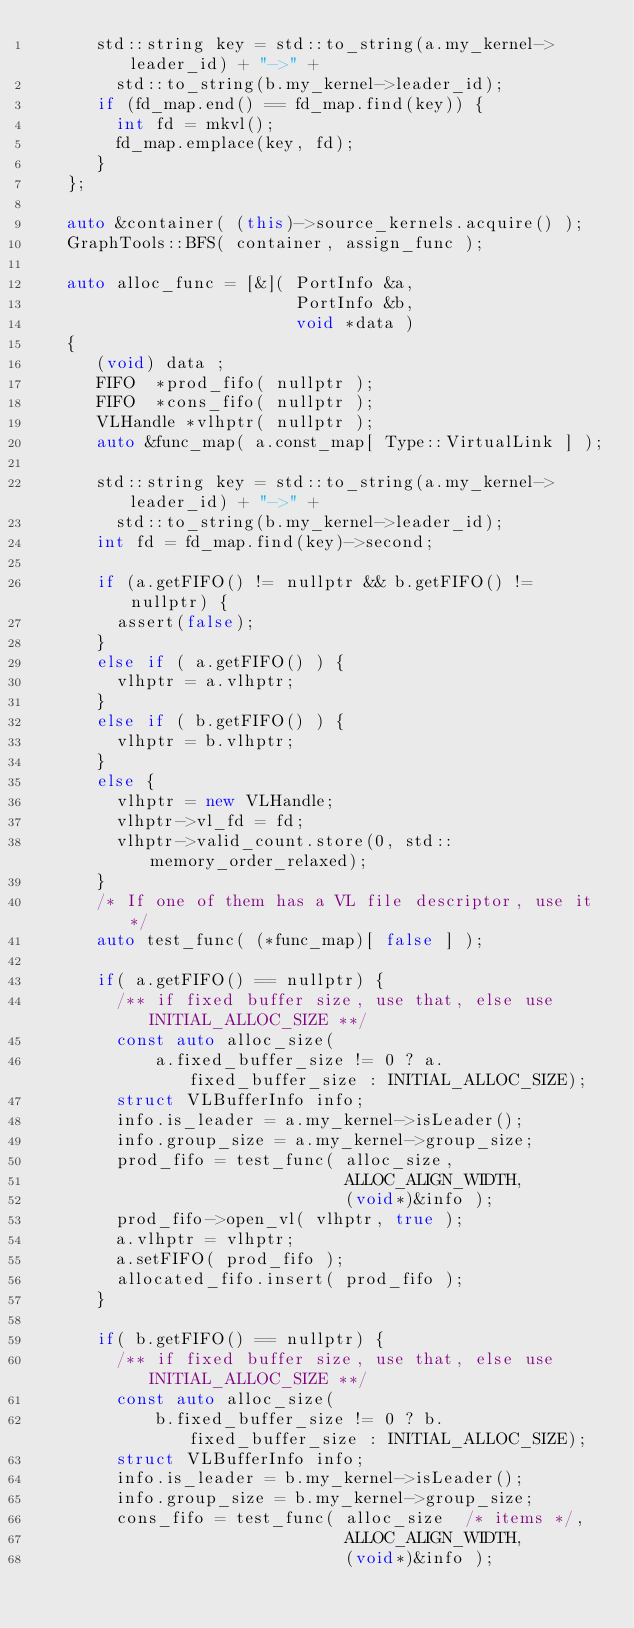<code> <loc_0><loc_0><loc_500><loc_500><_C++_>      std::string key = std::to_string(a.my_kernel->leader_id) + "->" +
        std::to_string(b.my_kernel->leader_id);
      if (fd_map.end() == fd_map.find(key)) {
        int fd = mkvl();
        fd_map.emplace(key, fd);
      }
   };

   auto &container( (this)->source_kernels.acquire() );
   GraphTools::BFS( container, assign_func );

   auto alloc_func = [&]( PortInfo &a,
                          PortInfo &b,
                          void *data )
   {
      (void) data ;
      FIFO  *prod_fifo( nullptr );
      FIFO  *cons_fifo( nullptr );
      VLHandle *vlhptr( nullptr );
      auto &func_map( a.const_map[ Type::VirtualLink ] ); 

      std::string key = std::to_string(a.my_kernel->leader_id) + "->" +
        std::to_string(b.my_kernel->leader_id);
      int fd = fd_map.find(key)->second;

      if (a.getFIFO() != nullptr && b.getFIFO() != nullptr) {
        assert(false);
      }
      else if ( a.getFIFO() ) {
        vlhptr = a.vlhptr;
      }
      else if ( b.getFIFO() ) {
        vlhptr = b.vlhptr;
      }
      else {
        vlhptr = new VLHandle;
        vlhptr->vl_fd = fd;
        vlhptr->valid_count.store(0, std::memory_order_relaxed);
      }
      /* If one of them has a VL file descriptor, use it */
      auto test_func( (*func_map)[ false ] );

      if( a.getFIFO() == nullptr) {
        /** if fixed buffer size, use that, else use INITIAL_ALLOC_SIZE **/
        const auto alloc_size( 
            a.fixed_buffer_size != 0 ? a.fixed_buffer_size : INITIAL_ALLOC_SIZE); 
        struct VLBufferInfo info;
        info.is_leader = a.my_kernel->isLeader();
        info.group_size = a.my_kernel->group_size;
        prod_fifo = test_func( alloc_size,
                               ALLOC_ALIGN_WIDTH,
                               (void*)&info );
        prod_fifo->open_vl( vlhptr, true );
        a.vlhptr = vlhptr;
        a.setFIFO( prod_fifo );
        allocated_fifo.insert( prod_fifo );
      }

      if( b.getFIFO() == nullptr) {
        /** if fixed buffer size, use that, else use INITIAL_ALLOC_SIZE **/
        const auto alloc_size( 
            b.fixed_buffer_size != 0 ? b.fixed_buffer_size : INITIAL_ALLOC_SIZE); 
        struct VLBufferInfo info;
        info.is_leader = b.my_kernel->isLeader();
        info.group_size = b.my_kernel->group_size;
        cons_fifo = test_func( alloc_size  /* items */,
                               ALLOC_ALIGN_WIDTH,
                               (void*)&info );</code> 